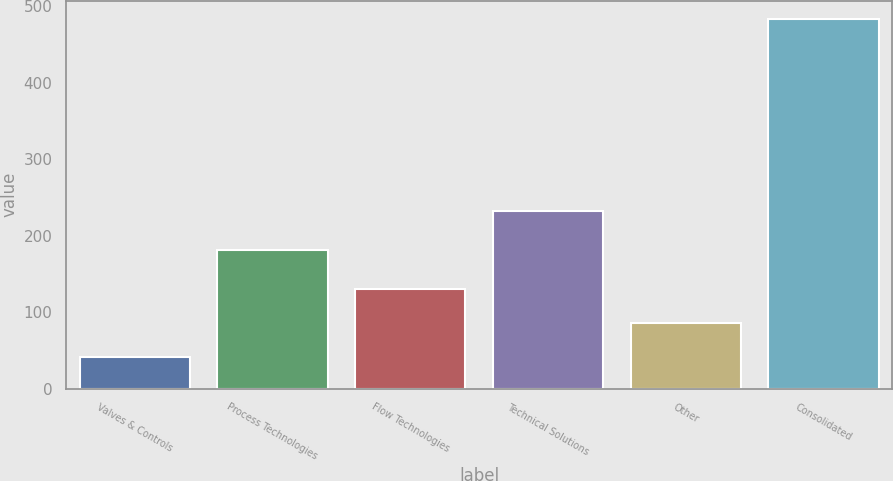Convert chart to OTSL. <chart><loc_0><loc_0><loc_500><loc_500><bar_chart><fcel>Valves & Controls<fcel>Process Technologies<fcel>Flow Technologies<fcel>Technical Solutions<fcel>Other<fcel>Consolidated<nl><fcel>41.8<fcel>181.1<fcel>130.14<fcel>232.1<fcel>85.97<fcel>483.5<nl></chart> 